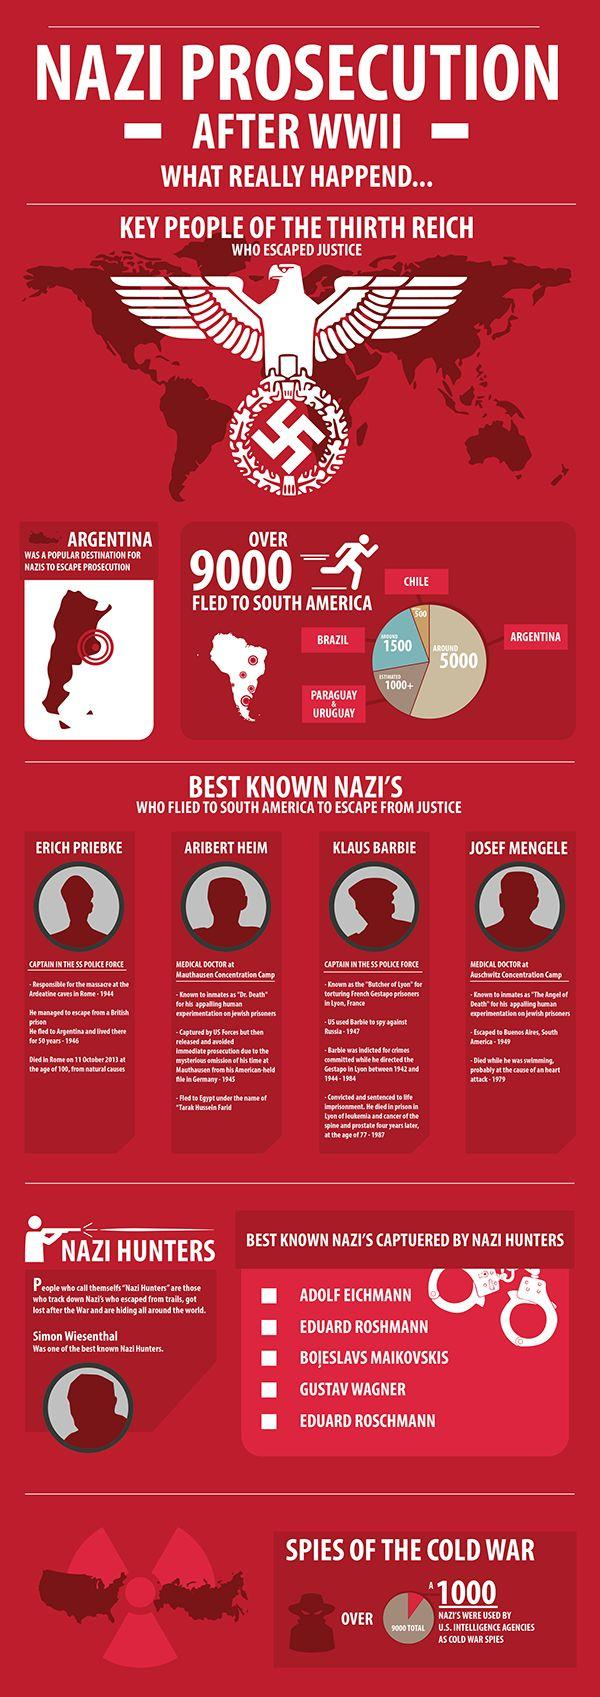Outline some significant characteristics in this image. During World War 2, many Nazis fled to South America, with Brazil being the second most common destination. The infamous Nazi official listed as second in the infographic, Eduard Roshmann, was caught by Nazi antagonists. During the Cold War, it is estimated that approximately 9,000 Nazi spies were active in various capacities. During World War II, a significant number of Nazis fled to South America, with the majority settling in Paraguay and Uruguay. During World War II, approximately 8000 Nazi spies were not working for the United States, according to historical records. 